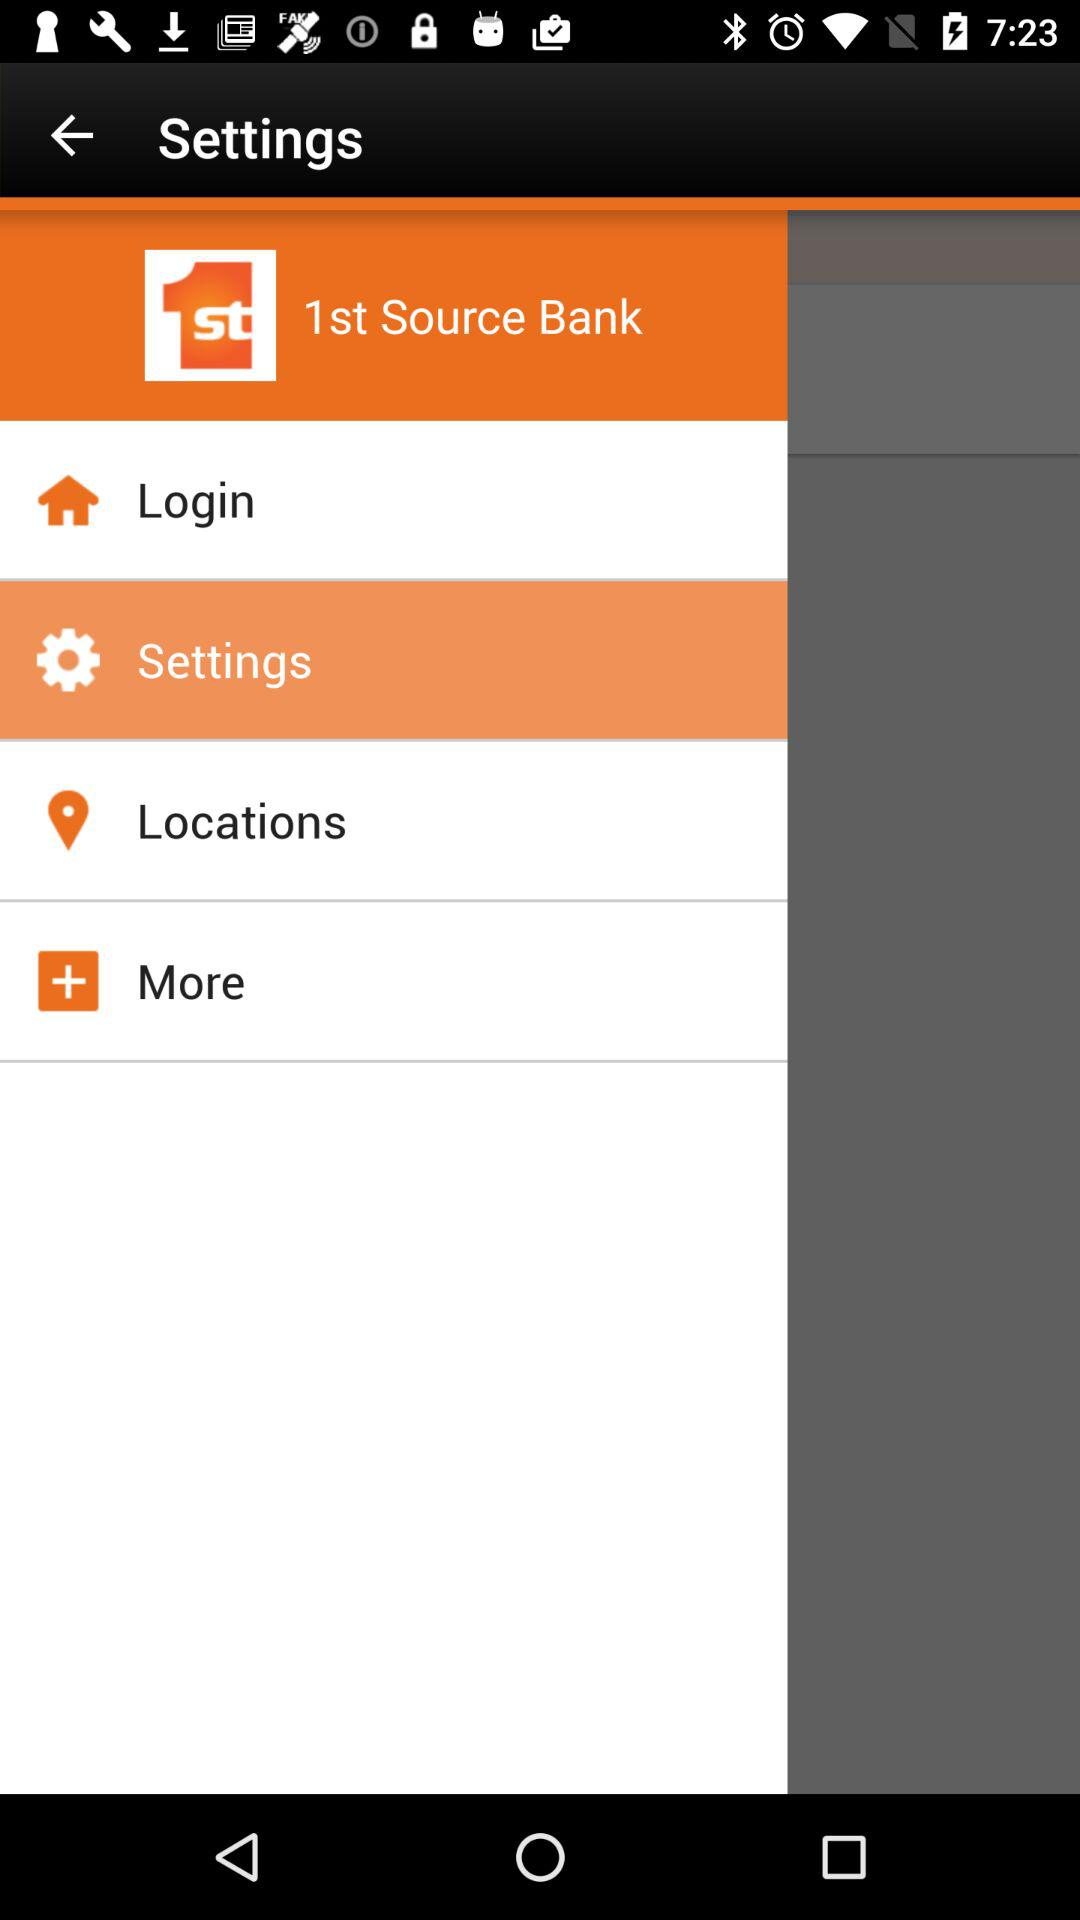Which option has been selected? The selected option is "Settings". 